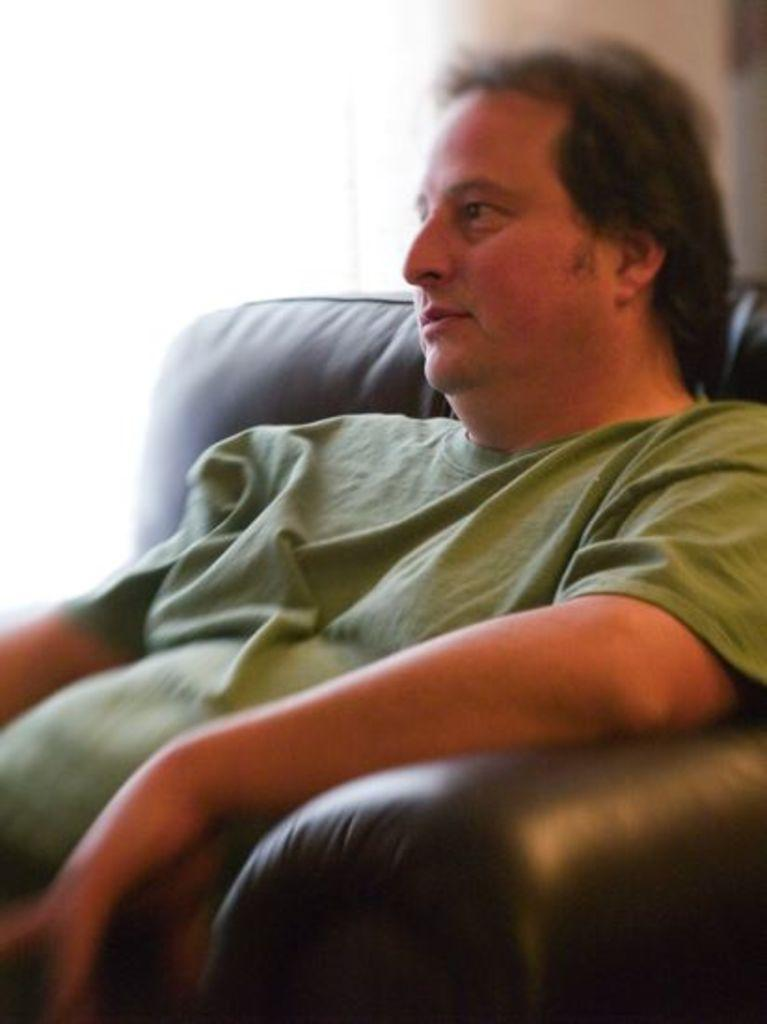What is the main subject of the image? There is a person in the image. What is the person doing in the image? The person is sitting on a sofa. What type of record can be seen on the plot in the image? There is no record or plot present in the image; it features a person sitting on a sofa. What kind of print is visible on the person's clothing in the image? There is no print visible on the person's clothing in the image; the person's clothing is not described in the provided facts. 